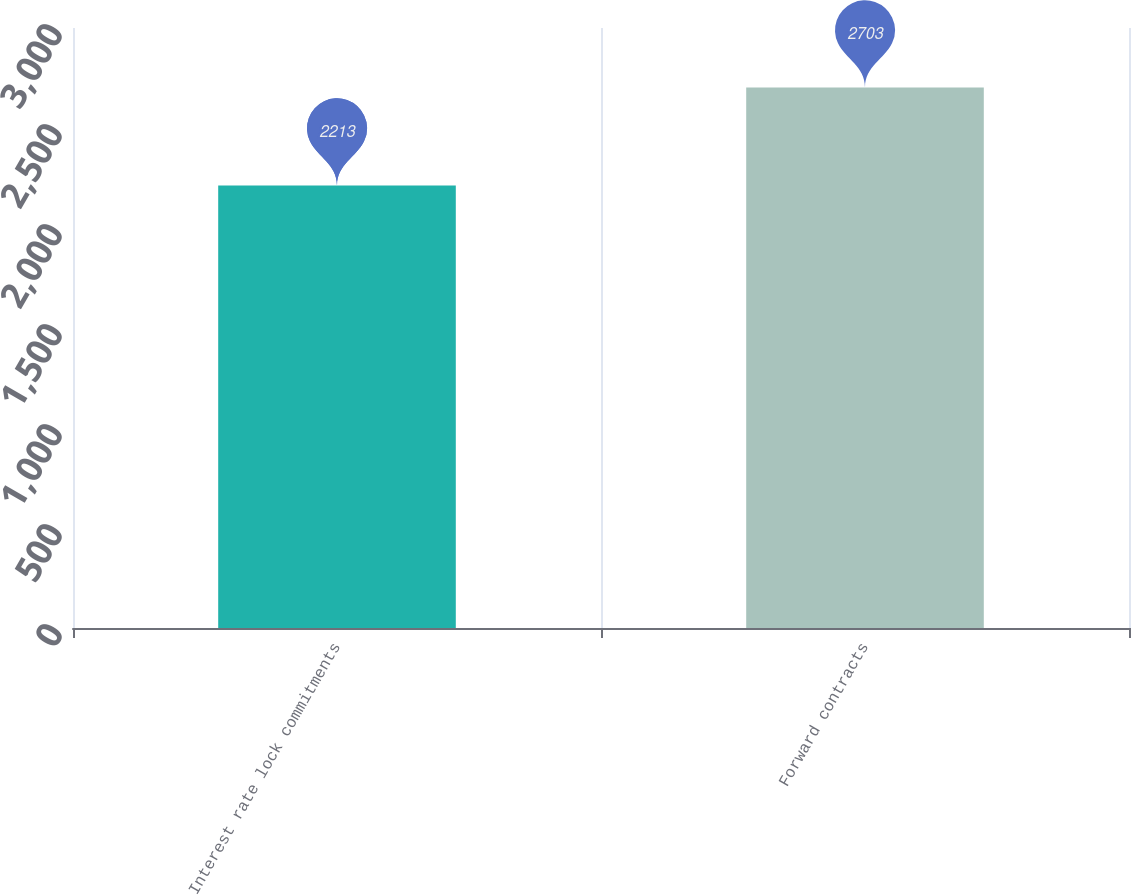Convert chart to OTSL. <chart><loc_0><loc_0><loc_500><loc_500><bar_chart><fcel>Interest rate lock commitments<fcel>Forward contracts<nl><fcel>2213<fcel>2703<nl></chart> 